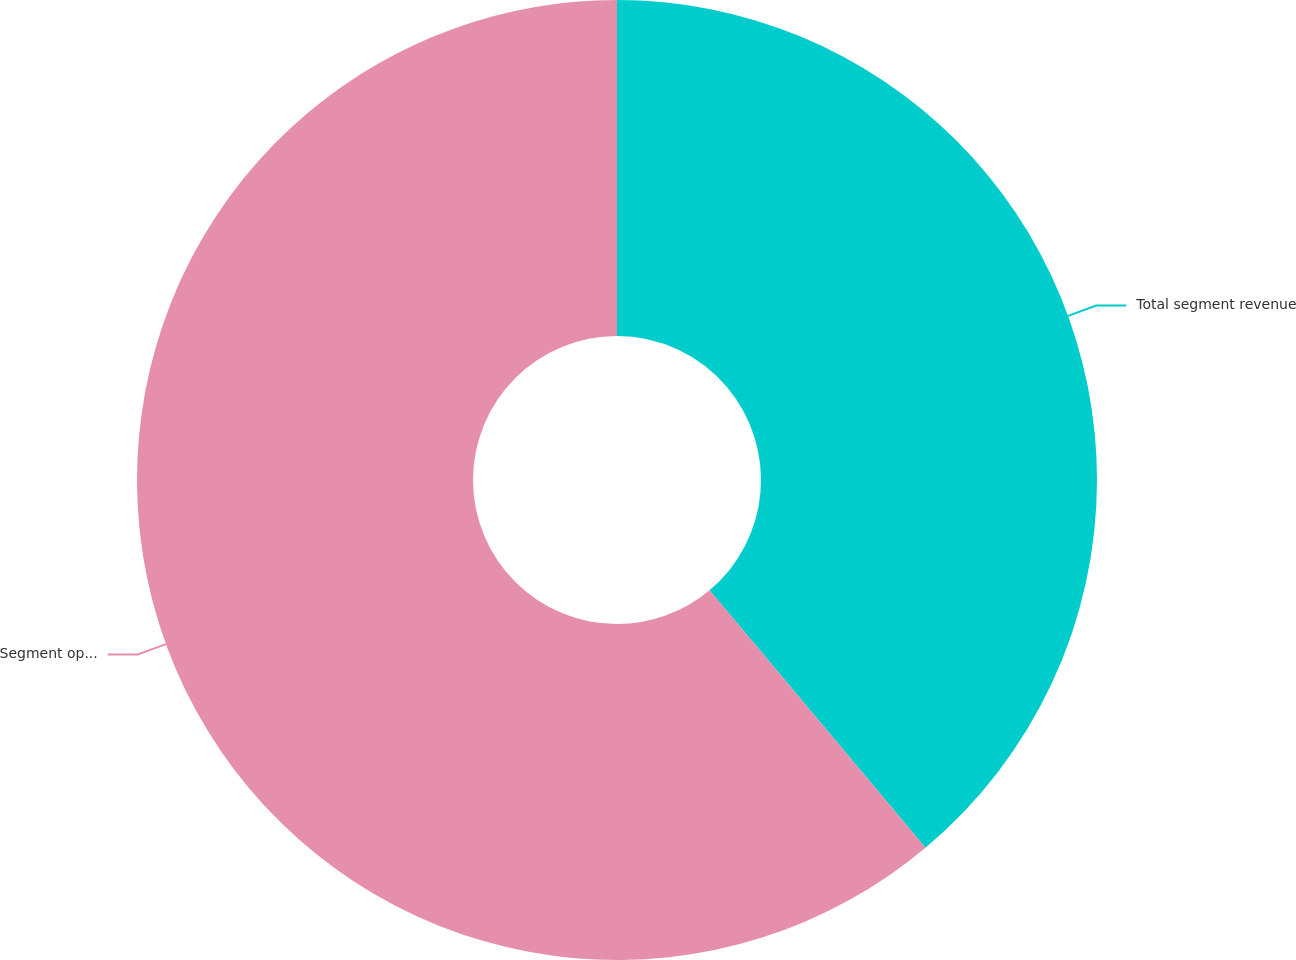Convert chart. <chart><loc_0><loc_0><loc_500><loc_500><pie_chart><fcel>Total segment revenue<fcel>Segment operating income<nl><fcel>38.89%<fcel>61.11%<nl></chart> 